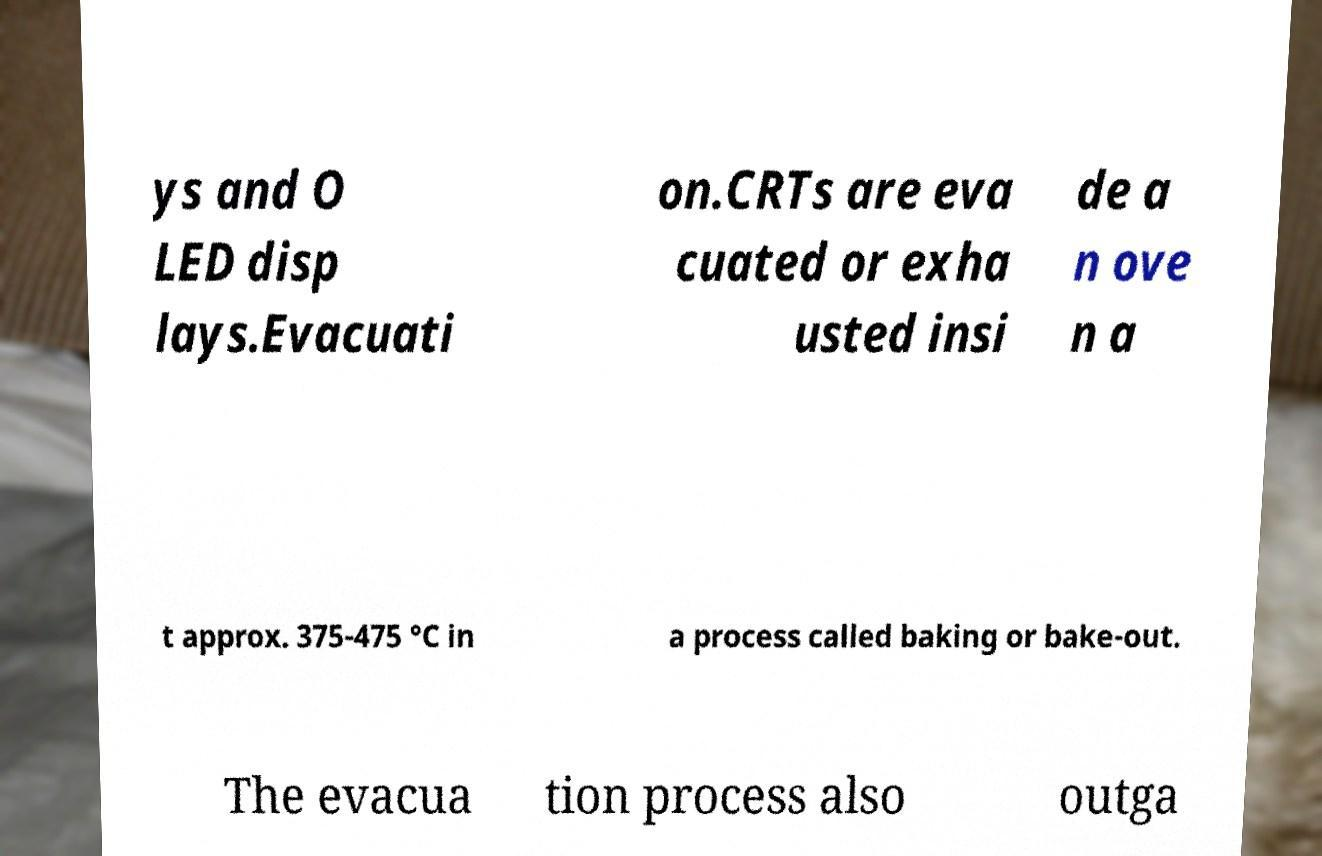Could you assist in decoding the text presented in this image and type it out clearly? ys and O LED disp lays.Evacuati on.CRTs are eva cuated or exha usted insi de a n ove n a t approx. 375-475 °C in a process called baking or bake-out. The evacua tion process also outga 